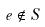<formula> <loc_0><loc_0><loc_500><loc_500>e \notin S</formula> 